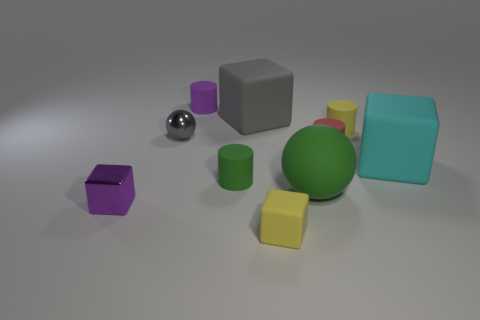How many other objects are the same material as the small gray object?
Offer a very short reply. 1. How many yellow matte things are there?
Give a very brief answer. 2. How many objects are small green rubber things or tiny things that are on the left side of the tiny yellow matte cube?
Make the answer very short. 4. There is a green thing behind the green rubber sphere; is it the same size as the large cyan cube?
Offer a very short reply. No. What number of metal objects are large green spheres or tiny yellow cylinders?
Ensure brevity in your answer.  0. How big is the purple object that is left of the gray sphere?
Offer a very short reply. Small. Is the tiny green matte object the same shape as the tiny red matte object?
Your answer should be compact. Yes. How many small objects are either gray metallic objects or matte spheres?
Give a very brief answer. 1. Are there any big objects in front of the green matte cylinder?
Your answer should be compact. Yes. Are there the same number of yellow matte cylinders in front of the small red cylinder and brown metallic cylinders?
Make the answer very short. Yes. 